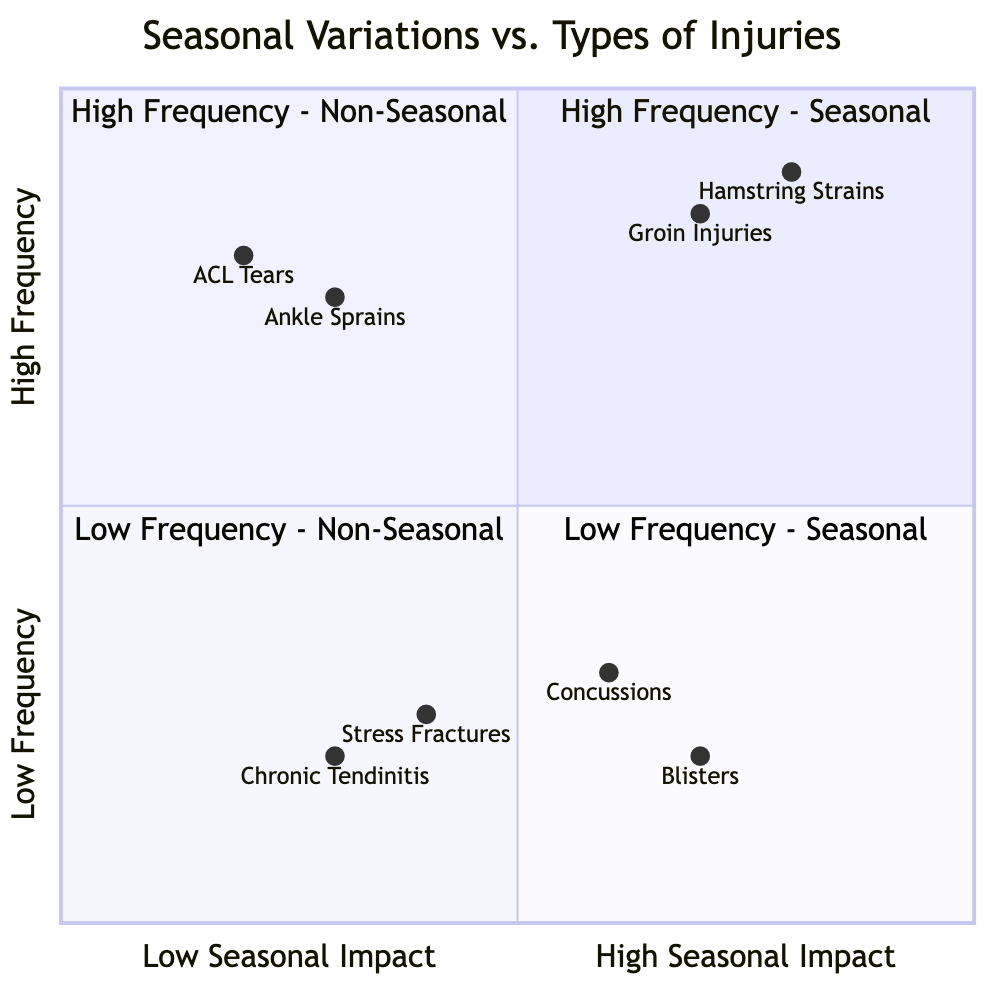What types of injuries are in the High Frequency - Seasonal quadrant? The High Frequency - Seasonal quadrant consists of two types of injuries, which are listed directly in the quadrant. They are Hamstring Strains and Groin Injuries.
Answer: Hamstring Strains, Groin Injuries How many injury types are categorized as Low Frequency - Seasonal? The Low Frequency - Seasonal quadrant includes two types of injuries, which are Concussions and Blisters. Counting the injuries gives a total of two in this quadrant.
Answer: 2 What is the main seasonal variation associated with ACL Tears? ACL Tears fall under the High Frequency - Non-Seasonal quadrant, which means they are associated with conditions like Year-Round Practice and Off-Season Conditioning, but do not exhibit a significant seasonal variation. Hence, they don't have a specific seasonal aspect directly attached to them.
Answer: Year-Round Practice, Off-Season Conditioning Which quadrant contains Stress Fractures? Stress Fractures are located in the Low Frequency - Non-Seasonal quadrant according to the diagram, which categorizes them based on their frequency of occurrence and their lack of seasonal impact.
Answer: Low Frequency - Non-Seasonal What is the highest frequency injury listed in the Low Frequency - Seasonal quadrant? The Low Frequency - Seasonal quadrant includes Concussions and Blisters. Since both of these injuries are classified as low frequency, we can compare their characteristics based on the diagram. Concussions have a slightly higher frequency value than Blisters, making them the highest in this quadrant.
Answer: Concussions How are Hamstring Strains affected by seasonal variations? Hamstring Strains, categorized under the High Frequency - Seasonal quadrant, are impacted primarily during specific seasonal activities such as Pre-Season Training and End of Season Playoffs. Hence, they exhibit high frequency during those times.
Answer: High Frequency during Pre-Season Training, End of Season Playoffs Which quadrant has the lowest frequency injuries? The quadrant designated for the lowest frequency injuries is the Low Frequency - Non-Seasonal quadrant. This is identified by assessing the quadrants and their characteristics, particularly focusing on frequency over seasonal considerations.
Answer: Low Frequency - Non-Seasonal What types of injuries are associated with Year-Round Practice? Year-Round Practice is linked with injuries classified in the High Frequency - Non-Seasonal quadrant. Those injuries are ACL Tears and Ankle Sprains, indicating their prevalence irrespective of seasonal changes.
Answer: ACL Tears, Ankle Sprains 